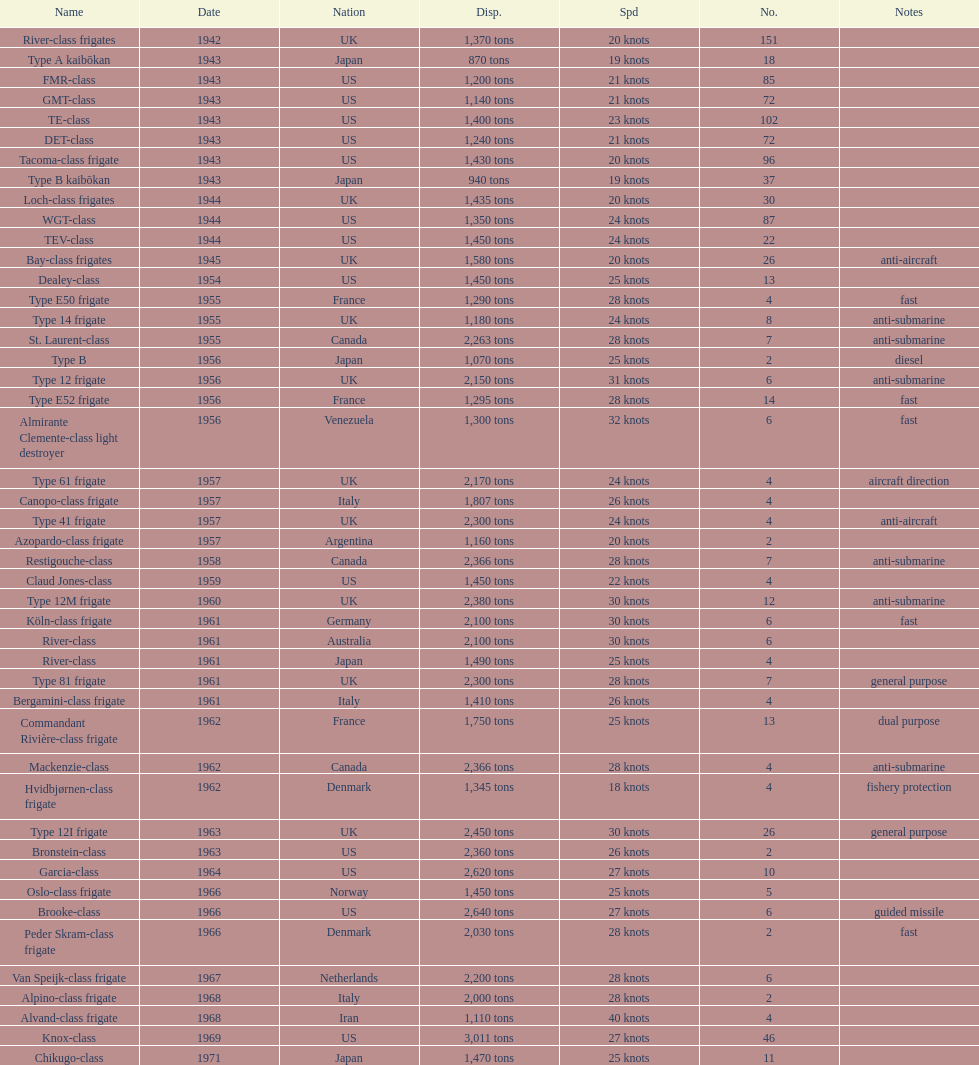How many tons does the te-class displace? 1,400 tons. 